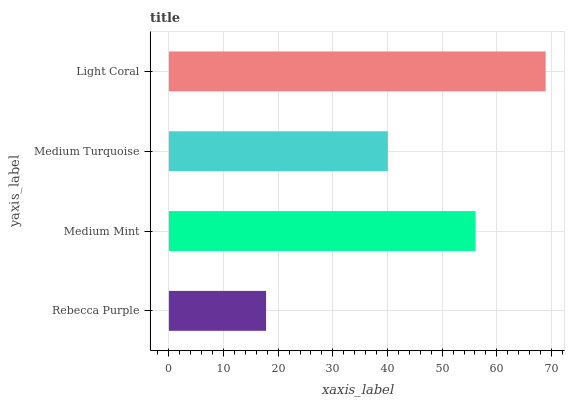Is Rebecca Purple the minimum?
Answer yes or no. Yes. Is Light Coral the maximum?
Answer yes or no. Yes. Is Medium Mint the minimum?
Answer yes or no. No. Is Medium Mint the maximum?
Answer yes or no. No. Is Medium Mint greater than Rebecca Purple?
Answer yes or no. Yes. Is Rebecca Purple less than Medium Mint?
Answer yes or no. Yes. Is Rebecca Purple greater than Medium Mint?
Answer yes or no. No. Is Medium Mint less than Rebecca Purple?
Answer yes or no. No. Is Medium Mint the high median?
Answer yes or no. Yes. Is Medium Turquoise the low median?
Answer yes or no. Yes. Is Medium Turquoise the high median?
Answer yes or no. No. Is Rebecca Purple the low median?
Answer yes or no. No. 